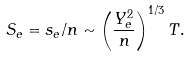Convert formula to latex. <formula><loc_0><loc_0><loc_500><loc_500>S _ { e } = s _ { e } / n \sim \left ( \frac { Y _ { e } ^ { 2 } } { n } \right ) ^ { 1 / 3 } T .</formula> 